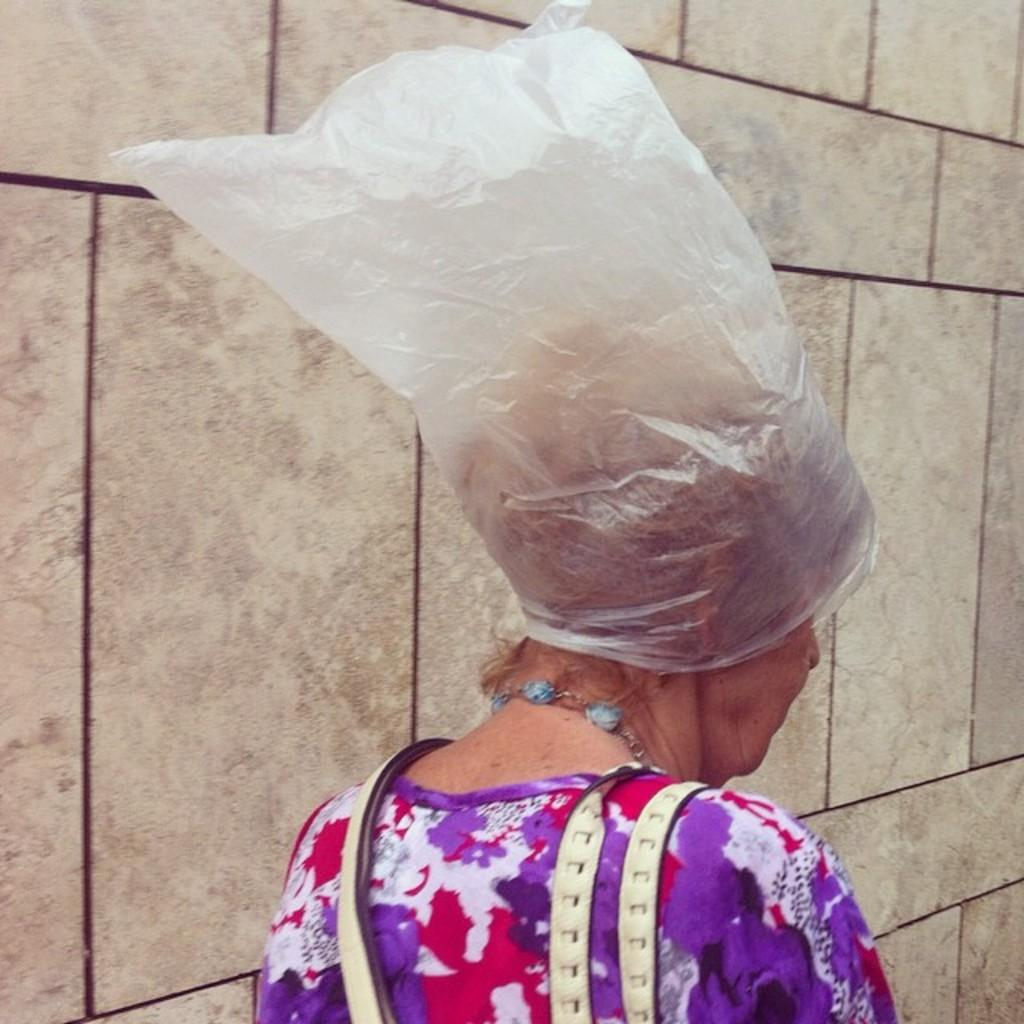Who is the main subject in the image? There is a woman in the image. What is the woman wearing on her head? The woman is wearing a plastic cover on her head. What can be seen in the background of the image? There is a wall in the background of the image. What thrilling fictional event is happening in the image? There is no thrilling fictional event happening in the image; it simply shows a woman wearing a plastic cover on her head with a wall in the background. 